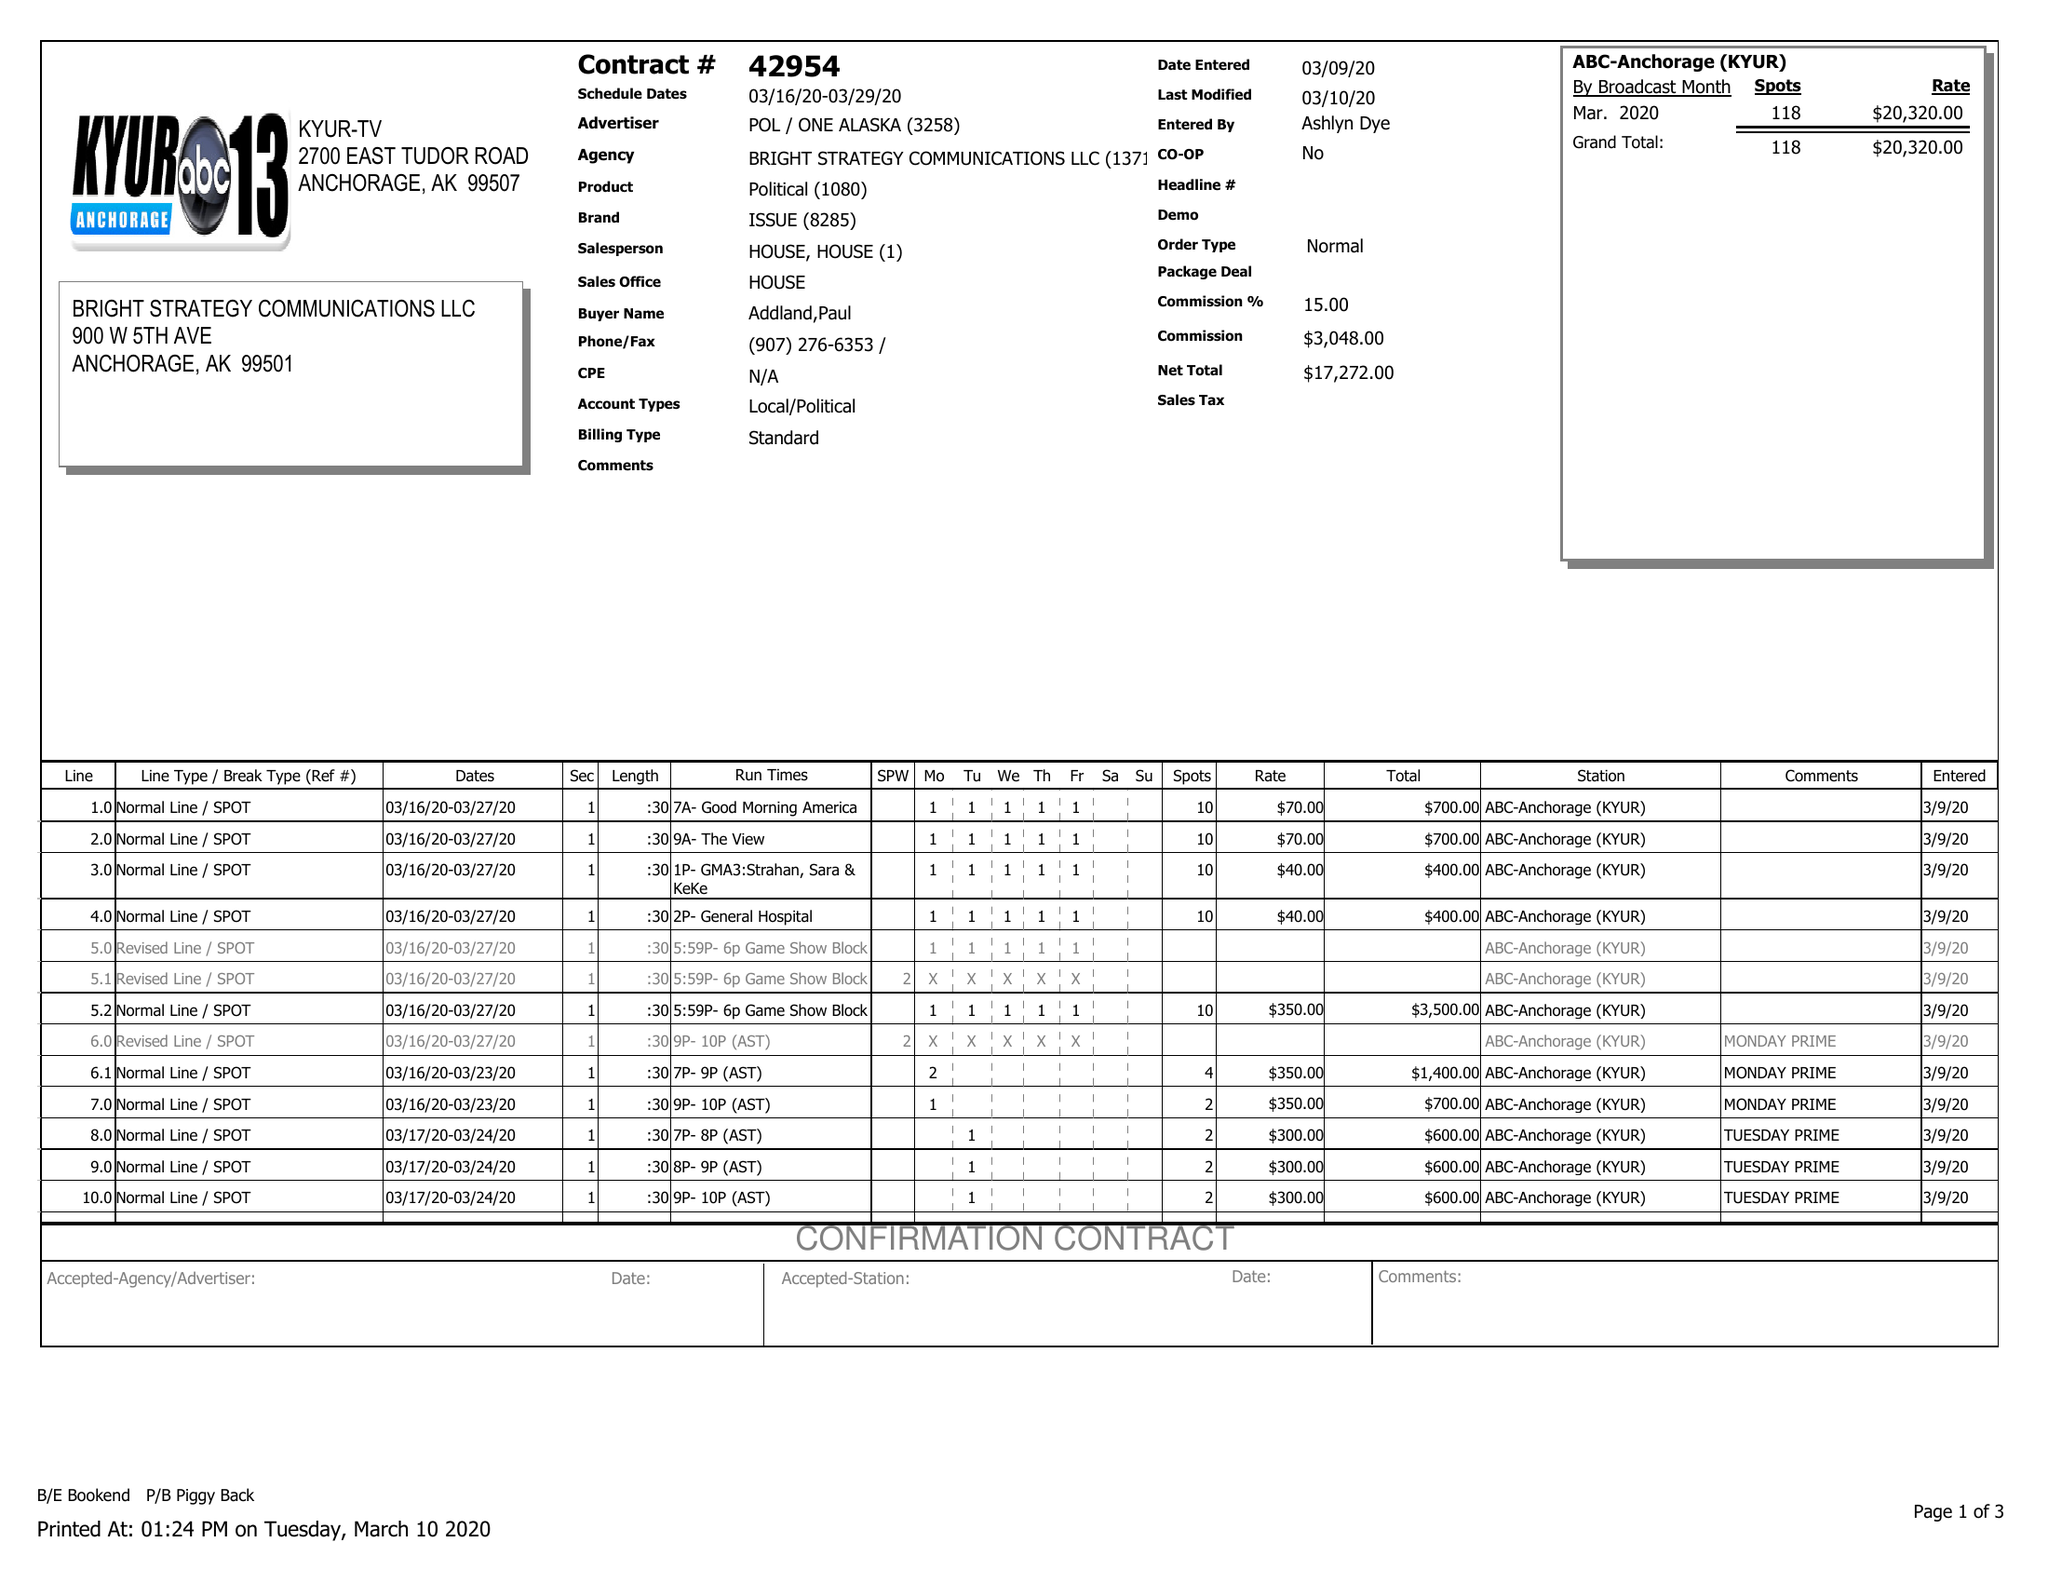What is the value for the flight_from?
Answer the question using a single word or phrase. 03/16/20 